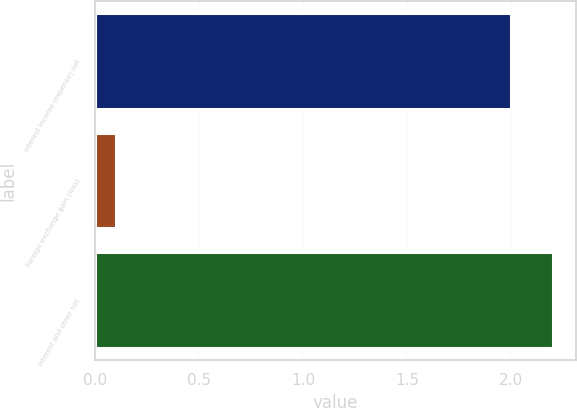Convert chart to OTSL. <chart><loc_0><loc_0><loc_500><loc_500><bar_chart><fcel>Interest income (expense) net<fcel>Foreign exchange gain (loss)<fcel>Interest and other net<nl><fcel>2<fcel>0.1<fcel>2.2<nl></chart> 